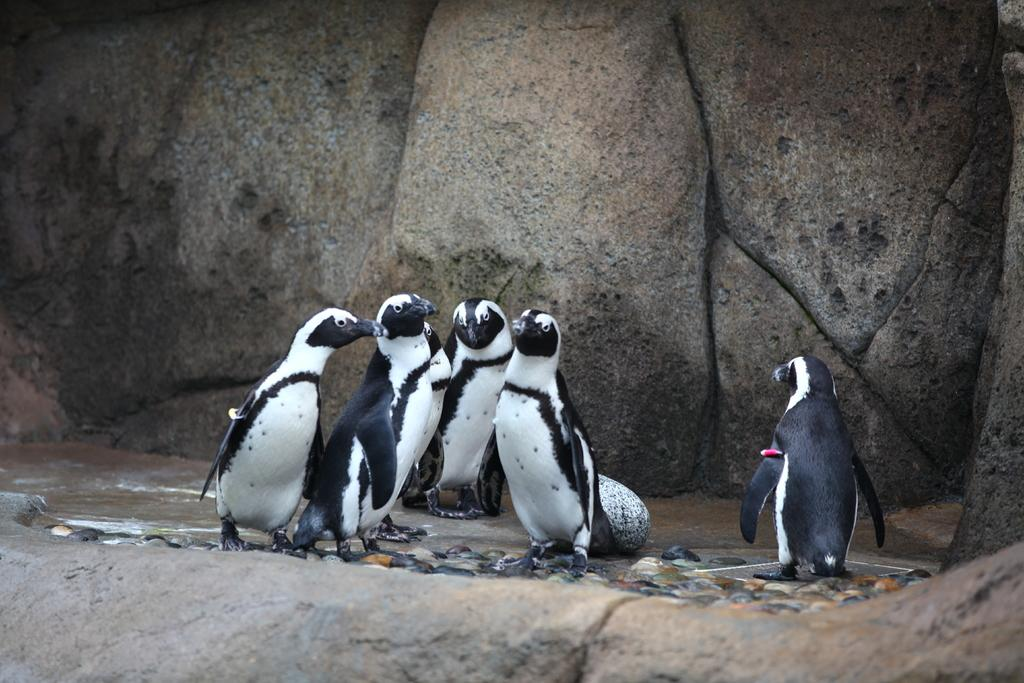What type of terrain is visible in the image? There is a rock hill in the image. What animals can be seen in the image? There are penguins in the middle of the image. What type of truck can be seen carrying a sack in the aftermath of the image? There is no truck, sack, or any reference to an aftermath in the image; it only features a rock hill and penguins. 